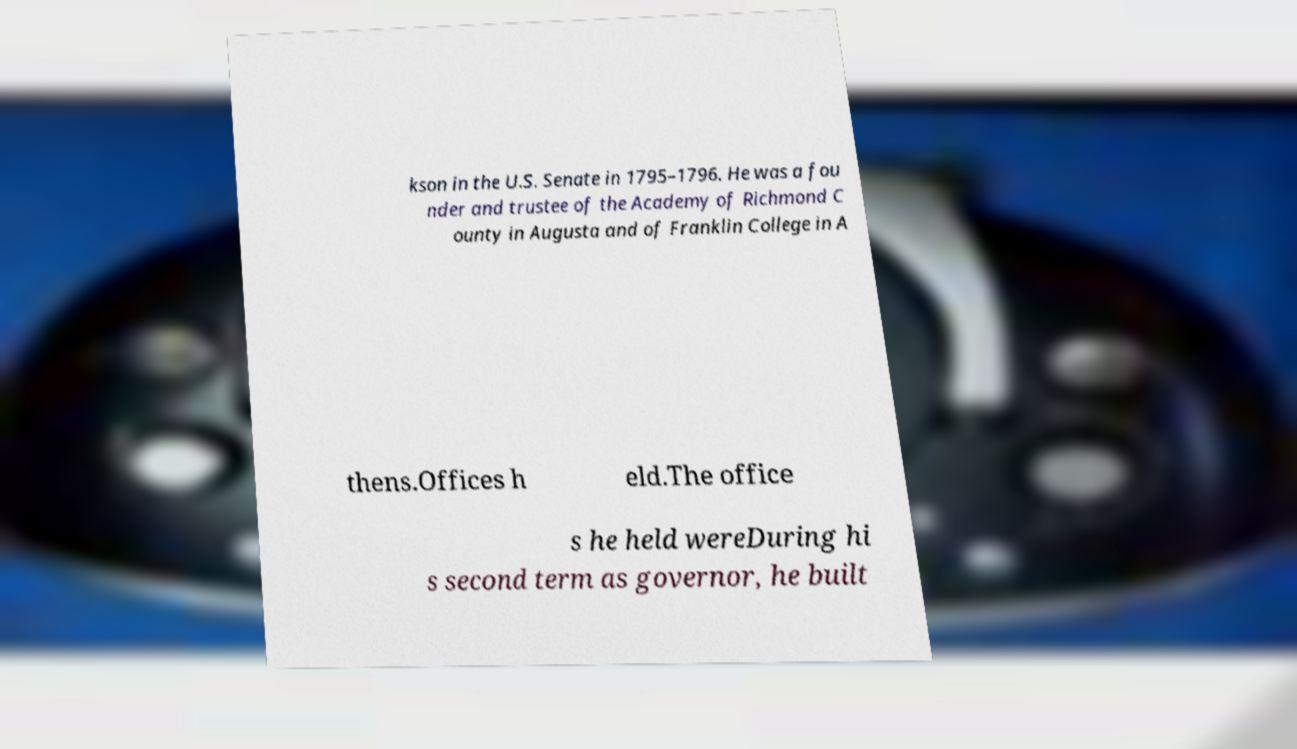Can you read and provide the text displayed in the image?This photo seems to have some interesting text. Can you extract and type it out for me? kson in the U.S. Senate in 1795–1796. He was a fou nder and trustee of the Academy of Richmond C ounty in Augusta and of Franklin College in A thens.Offices h eld.The office s he held wereDuring hi s second term as governor, he built 